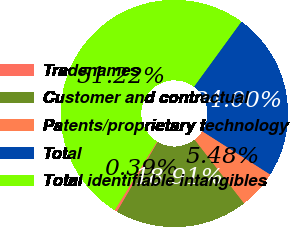Convert chart. <chart><loc_0><loc_0><loc_500><loc_500><pie_chart><fcel>Tradenames<fcel>Customer and contractual<fcel>Patents/proprietary technology<fcel>Total<fcel>Total identifiable intangibles<nl><fcel>0.39%<fcel>18.91%<fcel>5.48%<fcel>24.0%<fcel>51.22%<nl></chart> 